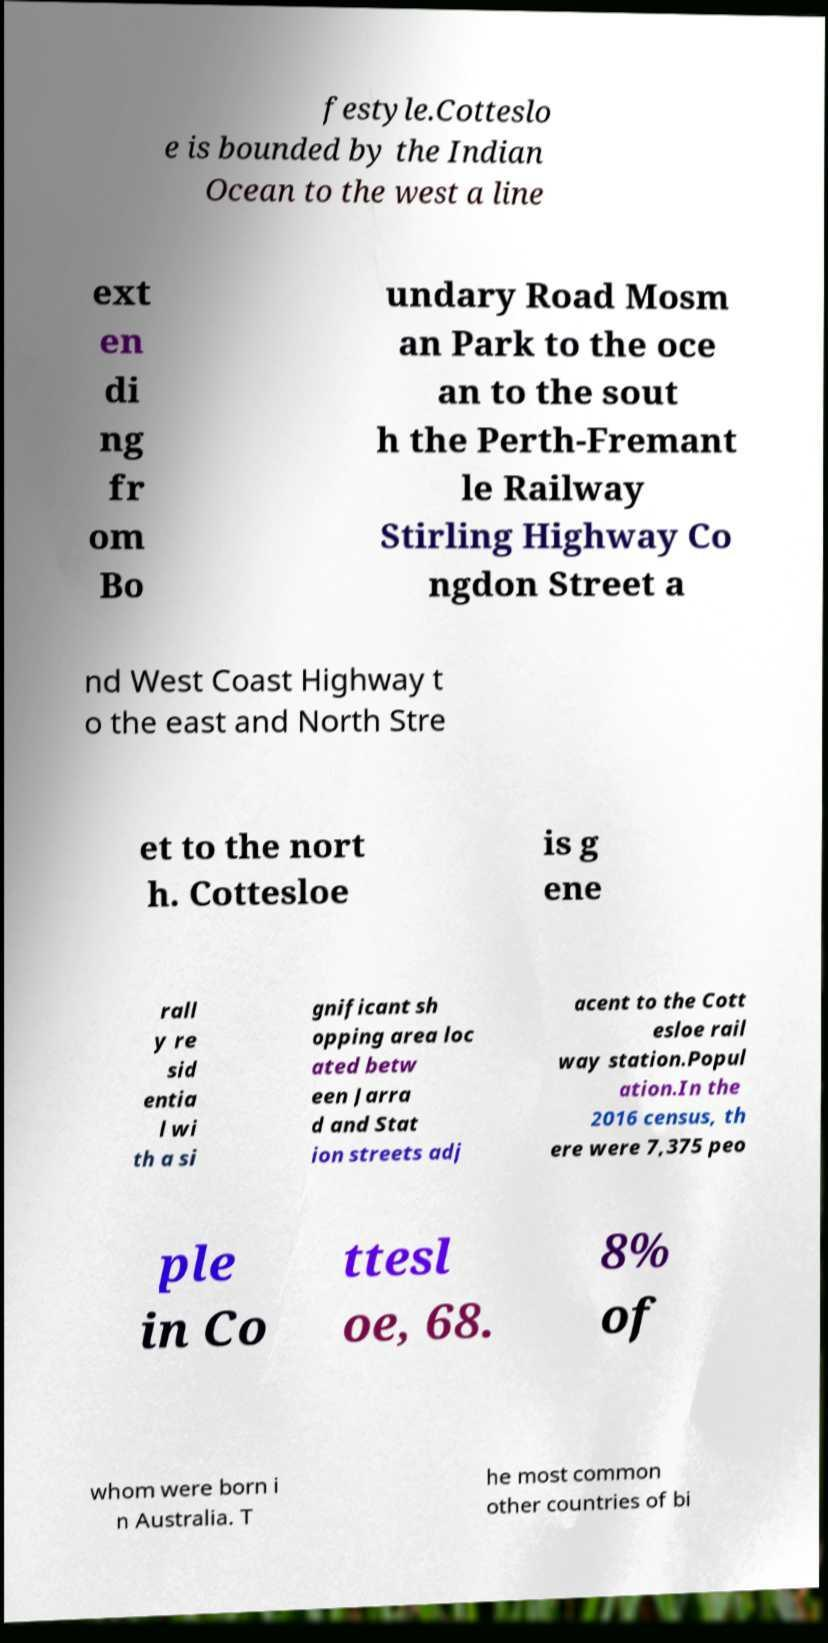Please read and relay the text visible in this image. What does it say? festyle.Cotteslo e is bounded by the Indian Ocean to the west a line ext en di ng fr om Bo undary Road Mosm an Park to the oce an to the sout h the Perth-Fremant le Railway Stirling Highway Co ngdon Street a nd West Coast Highway t o the east and North Stre et to the nort h. Cottesloe is g ene rall y re sid entia l wi th a si gnificant sh opping area loc ated betw een Jarra d and Stat ion streets adj acent to the Cott esloe rail way station.Popul ation.In the 2016 census, th ere were 7,375 peo ple in Co ttesl oe, 68. 8% of whom were born i n Australia. T he most common other countries of bi 